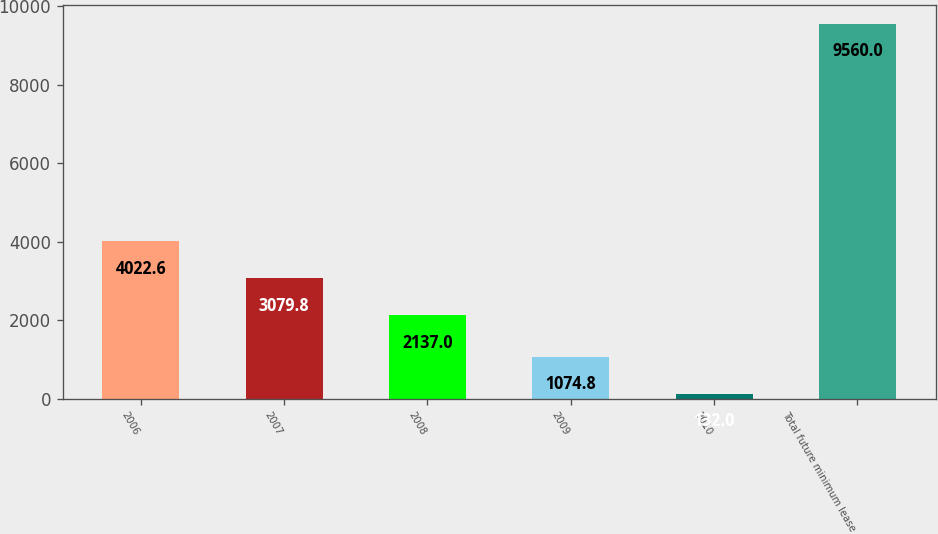Convert chart. <chart><loc_0><loc_0><loc_500><loc_500><bar_chart><fcel>2006<fcel>2007<fcel>2008<fcel>2009<fcel>2010<fcel>Total future minimum lease<nl><fcel>4022.6<fcel>3079.8<fcel>2137<fcel>1074.8<fcel>132<fcel>9560<nl></chart> 